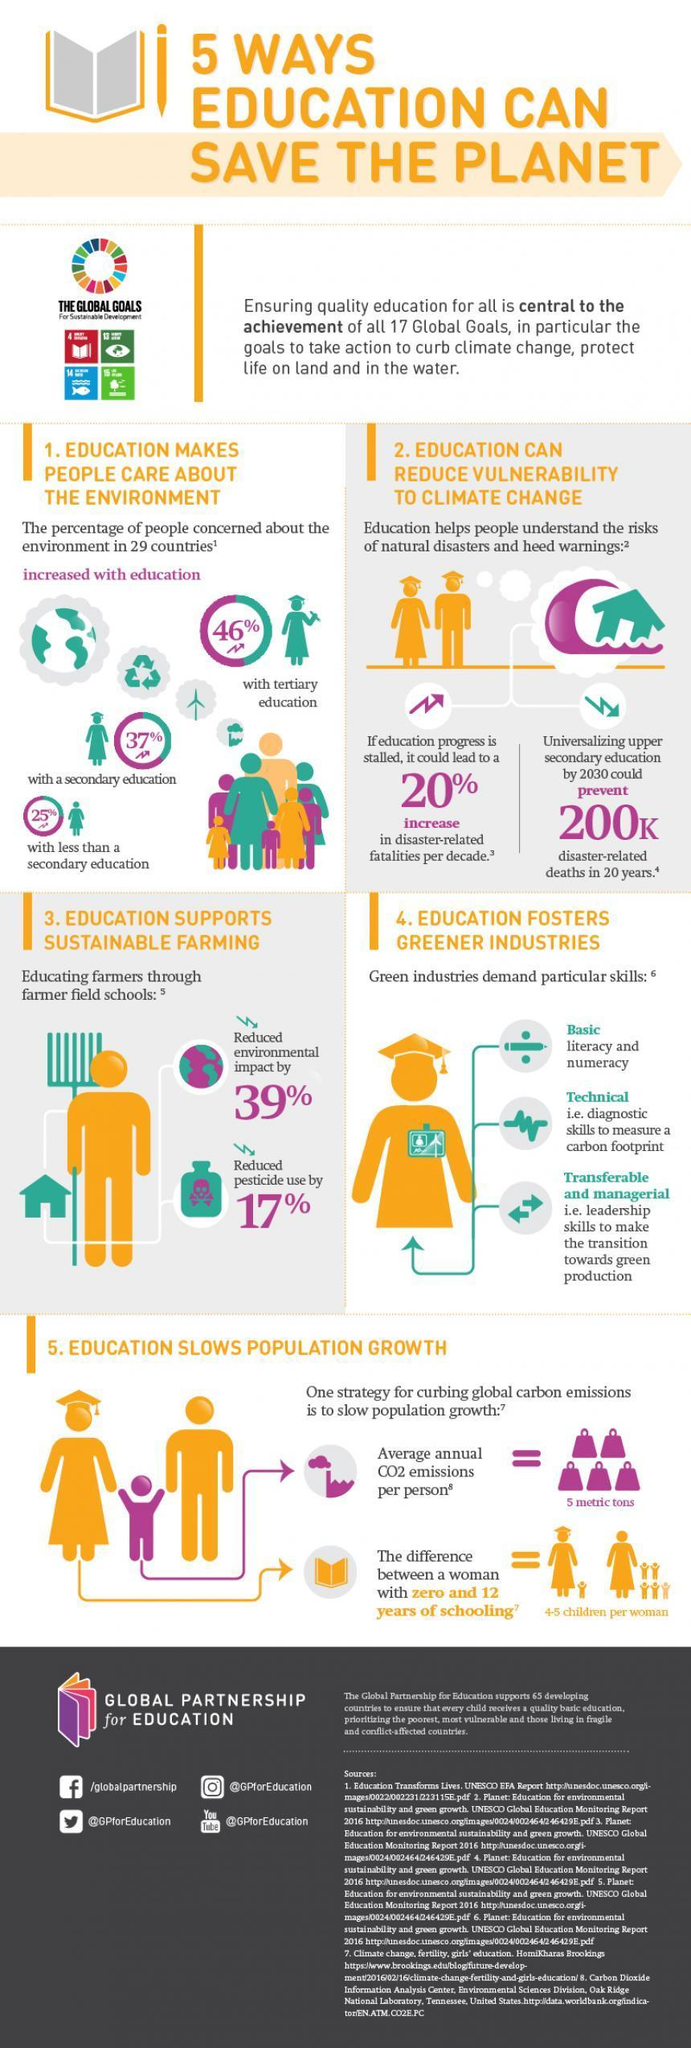What is the Facebook profile given?
Answer the question with a short phrase. /globalpartnership What is the channel name mentioned? @GPforEducation Who is concerned more about environment-those with tertiary, secondary or less than secondary education? tertiary education What is the Instagram profile given? @GPforEducation How much CO2 is emitted by one person per year? 5 metric tons What skills are needed for green industries? Basic, Technical, Transferable and managerial How many icons of people including children are shown in the infographic? 26 What is the Twitter handle given? @GPforEducation 